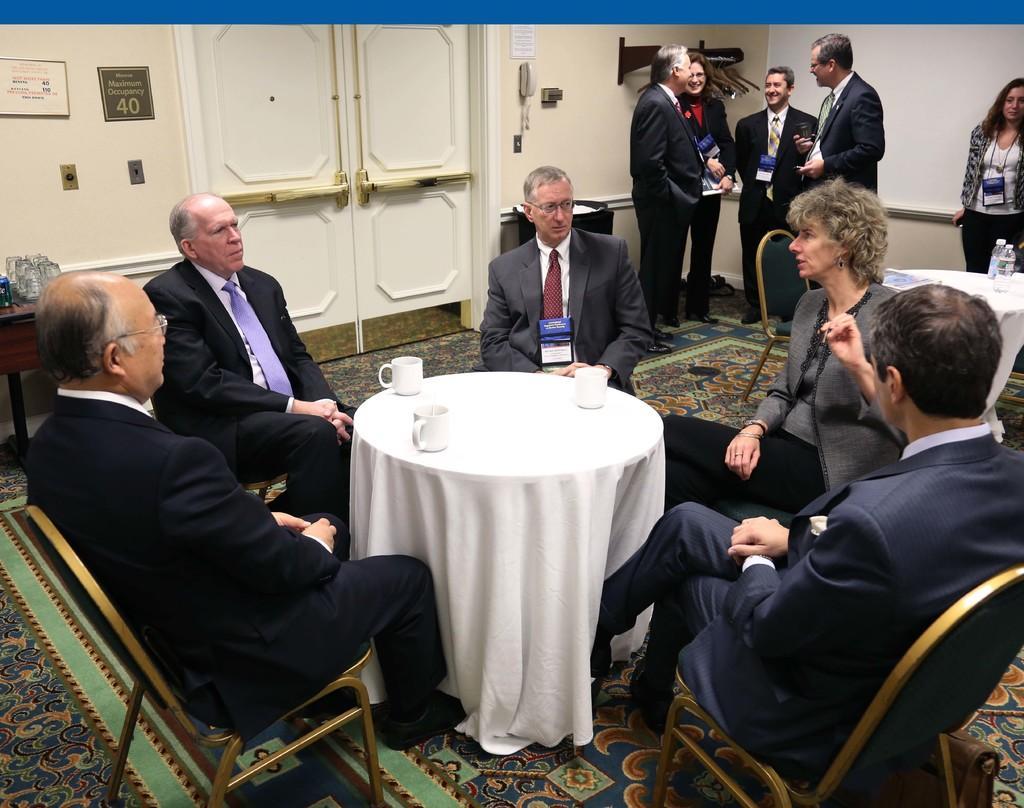Describe this image in one or two sentences. There is a group of a people. Some people are sitting in a chair. We can see in the background some persons are standing. There is a table. There is a cup on a table. 